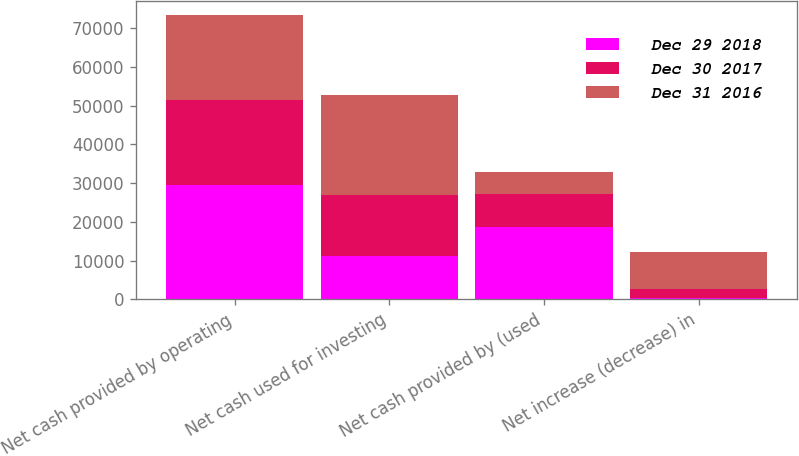<chart> <loc_0><loc_0><loc_500><loc_500><stacked_bar_chart><ecel><fcel>Net cash provided by operating<fcel>Net cash used for investing<fcel>Net cash provided by (used<fcel>Net increase (decrease) in<nl><fcel>Dec 29 2018<fcel>29432<fcel>11239<fcel>18607<fcel>414<nl><fcel>Dec 30 2017<fcel>22110<fcel>15762<fcel>8475<fcel>2127<nl><fcel>Dec 31 2016<fcel>21808<fcel>25817<fcel>5739<fcel>9748<nl></chart> 